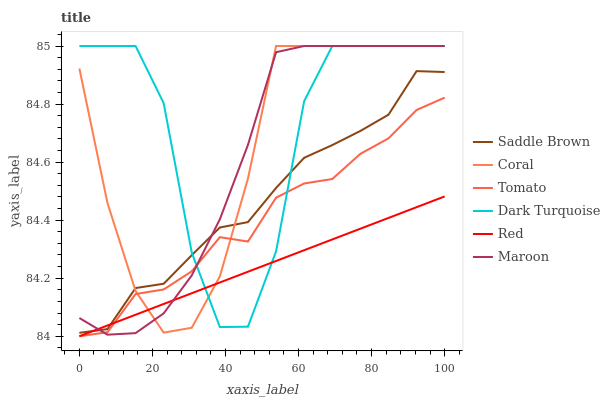Does Red have the minimum area under the curve?
Answer yes or no. Yes. Does Dark Turquoise have the maximum area under the curve?
Answer yes or no. Yes. Does Coral have the minimum area under the curve?
Answer yes or no. No. Does Coral have the maximum area under the curve?
Answer yes or no. No. Is Red the smoothest?
Answer yes or no. Yes. Is Dark Turquoise the roughest?
Answer yes or no. Yes. Is Coral the smoothest?
Answer yes or no. No. Is Coral the roughest?
Answer yes or no. No. Does Tomato have the lowest value?
Answer yes or no. Yes. Does Coral have the lowest value?
Answer yes or no. No. Does Maroon have the highest value?
Answer yes or no. Yes. Does Saddle Brown have the highest value?
Answer yes or no. No. Is Tomato less than Saddle Brown?
Answer yes or no. Yes. Is Saddle Brown greater than Tomato?
Answer yes or no. Yes. Does Red intersect Tomato?
Answer yes or no. Yes. Is Red less than Tomato?
Answer yes or no. No. Is Red greater than Tomato?
Answer yes or no. No. Does Tomato intersect Saddle Brown?
Answer yes or no. No. 